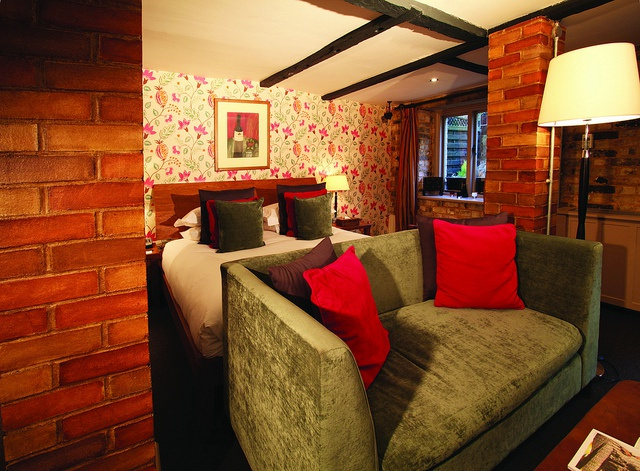Describe the objects in this image and their specific colors. I can see couch in gray, black, olive, and maroon tones and bed in gray, black, tan, maroon, and brown tones in this image. 